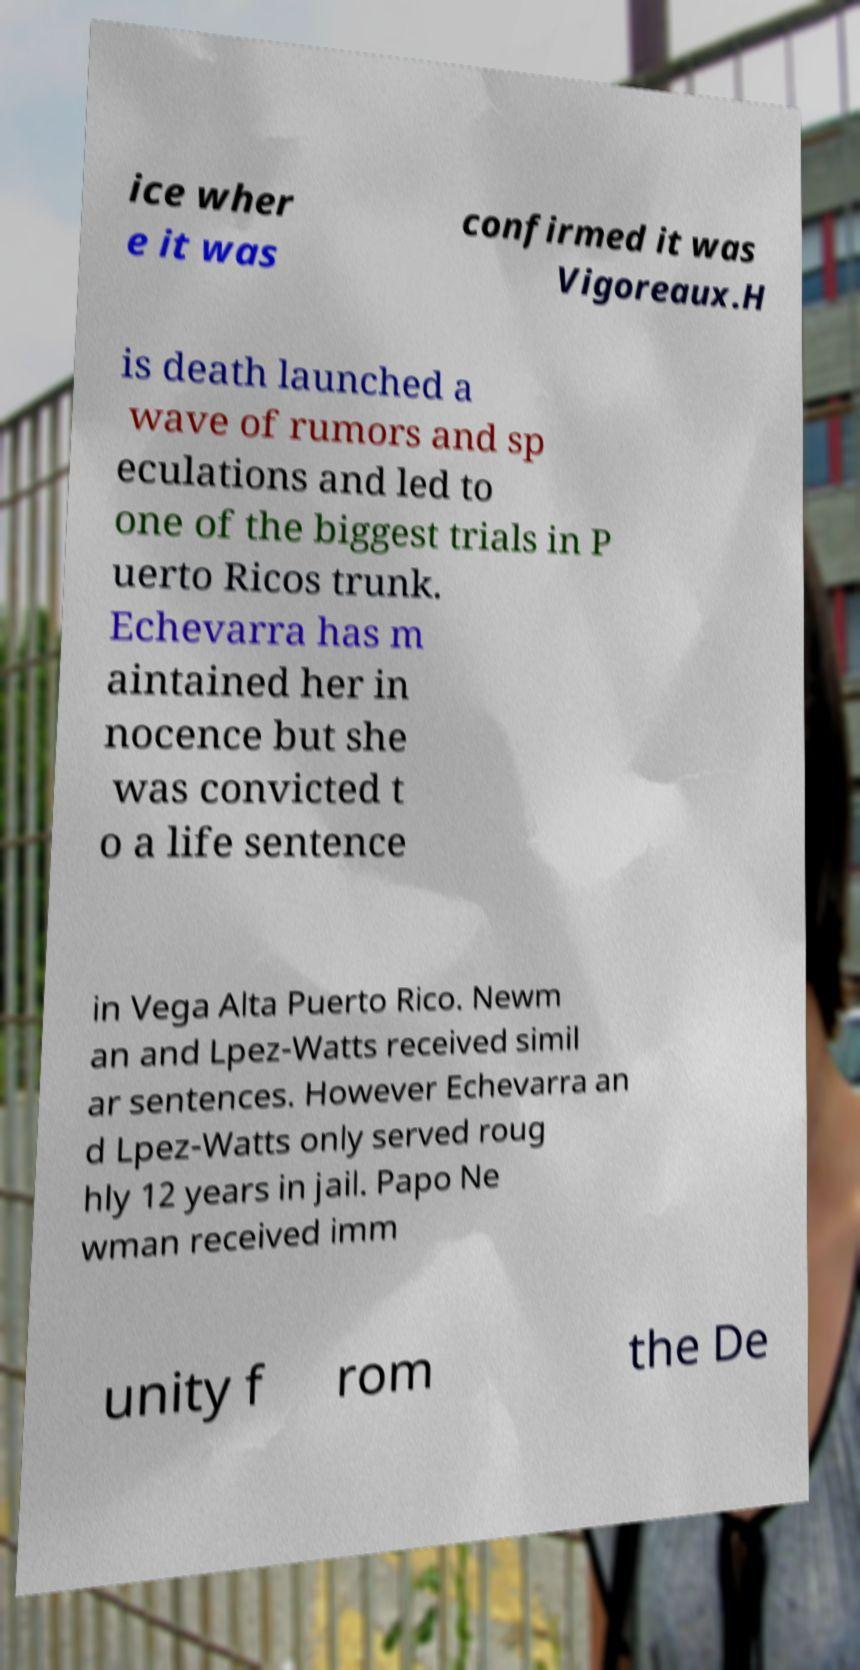I need the written content from this picture converted into text. Can you do that? ice wher e it was confirmed it was Vigoreaux.H is death launched a wave of rumors and sp eculations and led to one of the biggest trials in P uerto Ricos trunk. Echevarra has m aintained her in nocence but she was convicted t o a life sentence in Vega Alta Puerto Rico. Newm an and Lpez-Watts received simil ar sentences. However Echevarra an d Lpez-Watts only served roug hly 12 years in jail. Papo Ne wman received imm unity f rom the De 